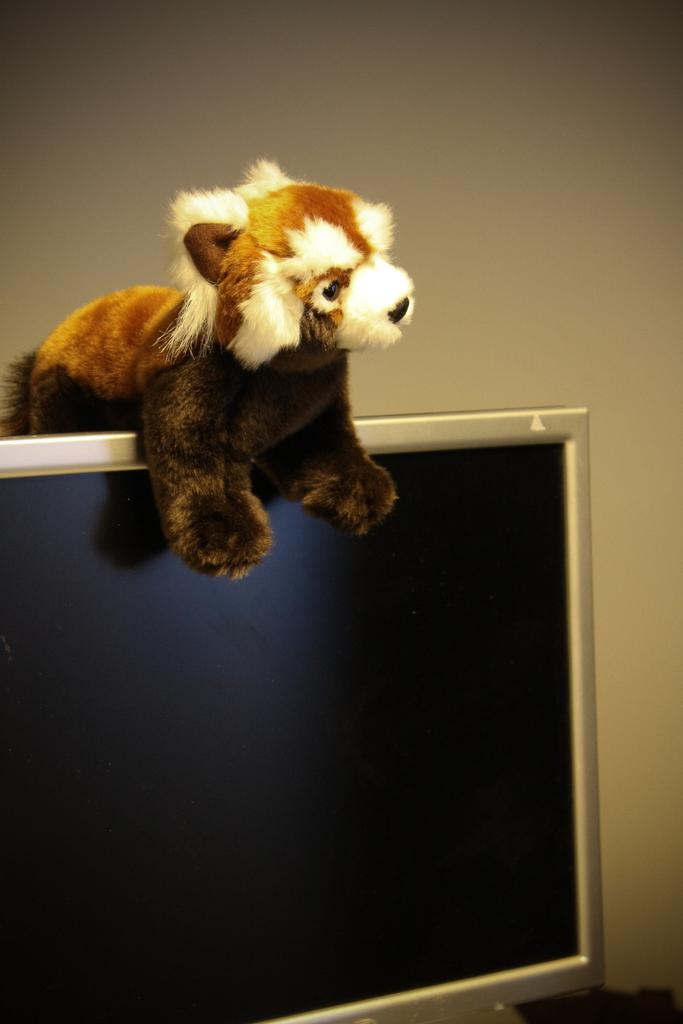What is the main object visible on the computer screen in the image? There is no information about the content on the computer screen. What is placed on top of the computer screen? There is a dog soft toy on top of the computer screen. What can be seen in the background of the image? There is a wall visible in the background of the image. How many flowers are visible on the dog soft toy in the image? There are no flowers present on the dog soft toy in the image. Can you describe the toes of the dog soft toy in the image? There is no dog soft toy with toes in the image, as it is a soft toy and not a real dog. 